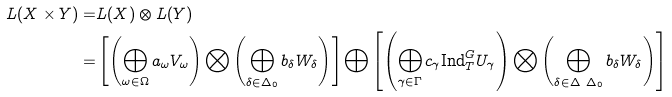<formula> <loc_0><loc_0><loc_500><loc_500>L ( X \times Y ) = & L ( X ) \otimes L ( Y ) \\ = & \left [ \left ( \bigoplus _ { \omega \in \Omega } a _ { \omega } V _ { \omega } \right ) \bigotimes \left ( \bigoplus _ { \delta \in \Delta _ { 0 } } b _ { \delta } W _ { \delta } \right ) \right ] \bigoplus \left [ \left ( \bigoplus _ { \gamma \in \Gamma } c _ { \gamma } \text {Ind} _ { T } ^ { G } U _ { \gamma } \right ) \bigotimes \left ( \bigoplus _ { \delta \in \Delta \ \Delta _ { 0 } } b _ { \delta } W _ { \delta } \right ) \right ]</formula> 